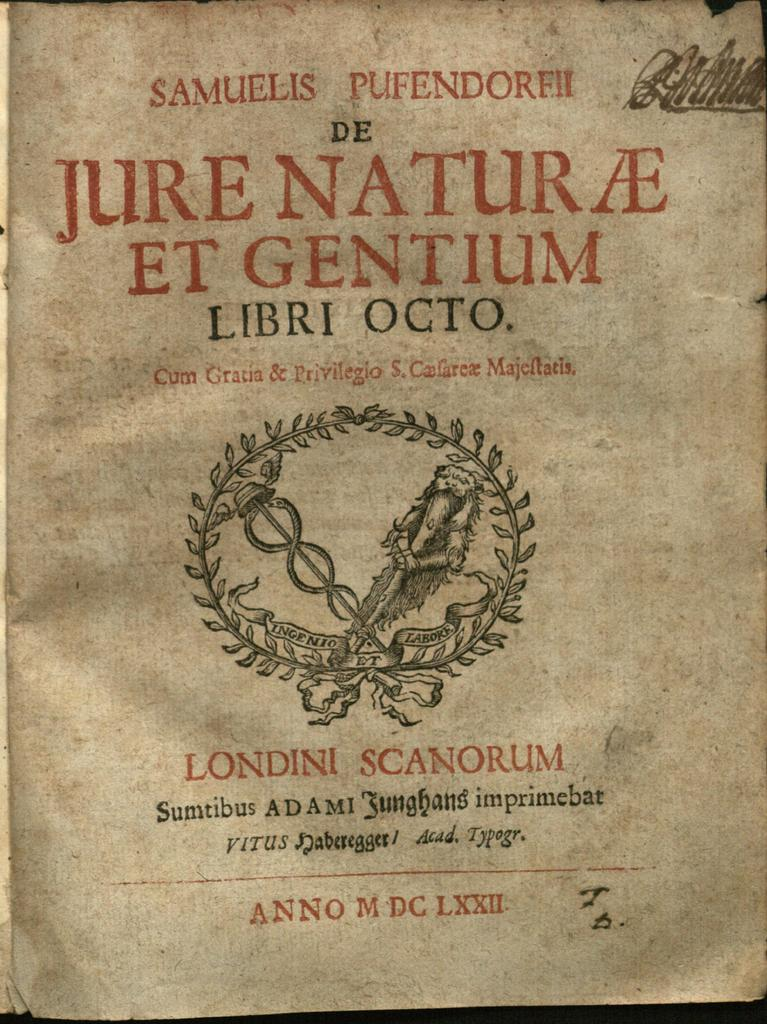<image>
Describe the image concisely. An old, yellowed page of a book written in Latin 